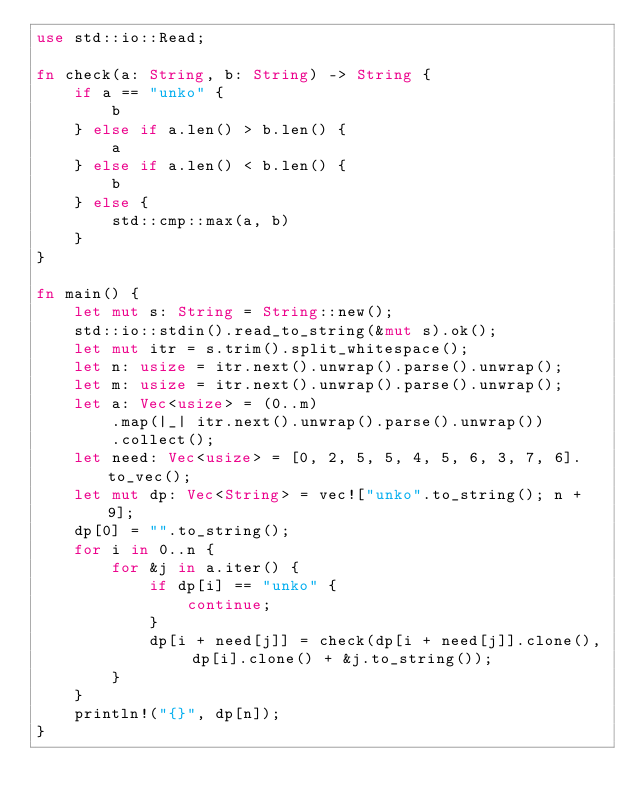<code> <loc_0><loc_0><loc_500><loc_500><_Rust_>use std::io::Read;

fn check(a: String, b: String) -> String {
    if a == "unko" {
        b
    } else if a.len() > b.len() {
        a
    } else if a.len() < b.len() {
        b
    } else {
        std::cmp::max(a, b)
    }
}

fn main() {
    let mut s: String = String::new();
    std::io::stdin().read_to_string(&mut s).ok();
    let mut itr = s.trim().split_whitespace();
    let n: usize = itr.next().unwrap().parse().unwrap();
    let m: usize = itr.next().unwrap().parse().unwrap();
    let a: Vec<usize> = (0..m)
        .map(|_| itr.next().unwrap().parse().unwrap())
        .collect();
    let need: Vec<usize> = [0, 2, 5, 5, 4, 5, 6, 3, 7, 6].to_vec();
    let mut dp: Vec<String> = vec!["unko".to_string(); n + 9];
    dp[0] = "".to_string();
    for i in 0..n {
        for &j in a.iter() {
            if dp[i] == "unko" {
                continue;
            }
            dp[i + need[j]] = check(dp[i + need[j]].clone(), dp[i].clone() + &j.to_string());
        }
    }
    println!("{}", dp[n]);
}</code> 